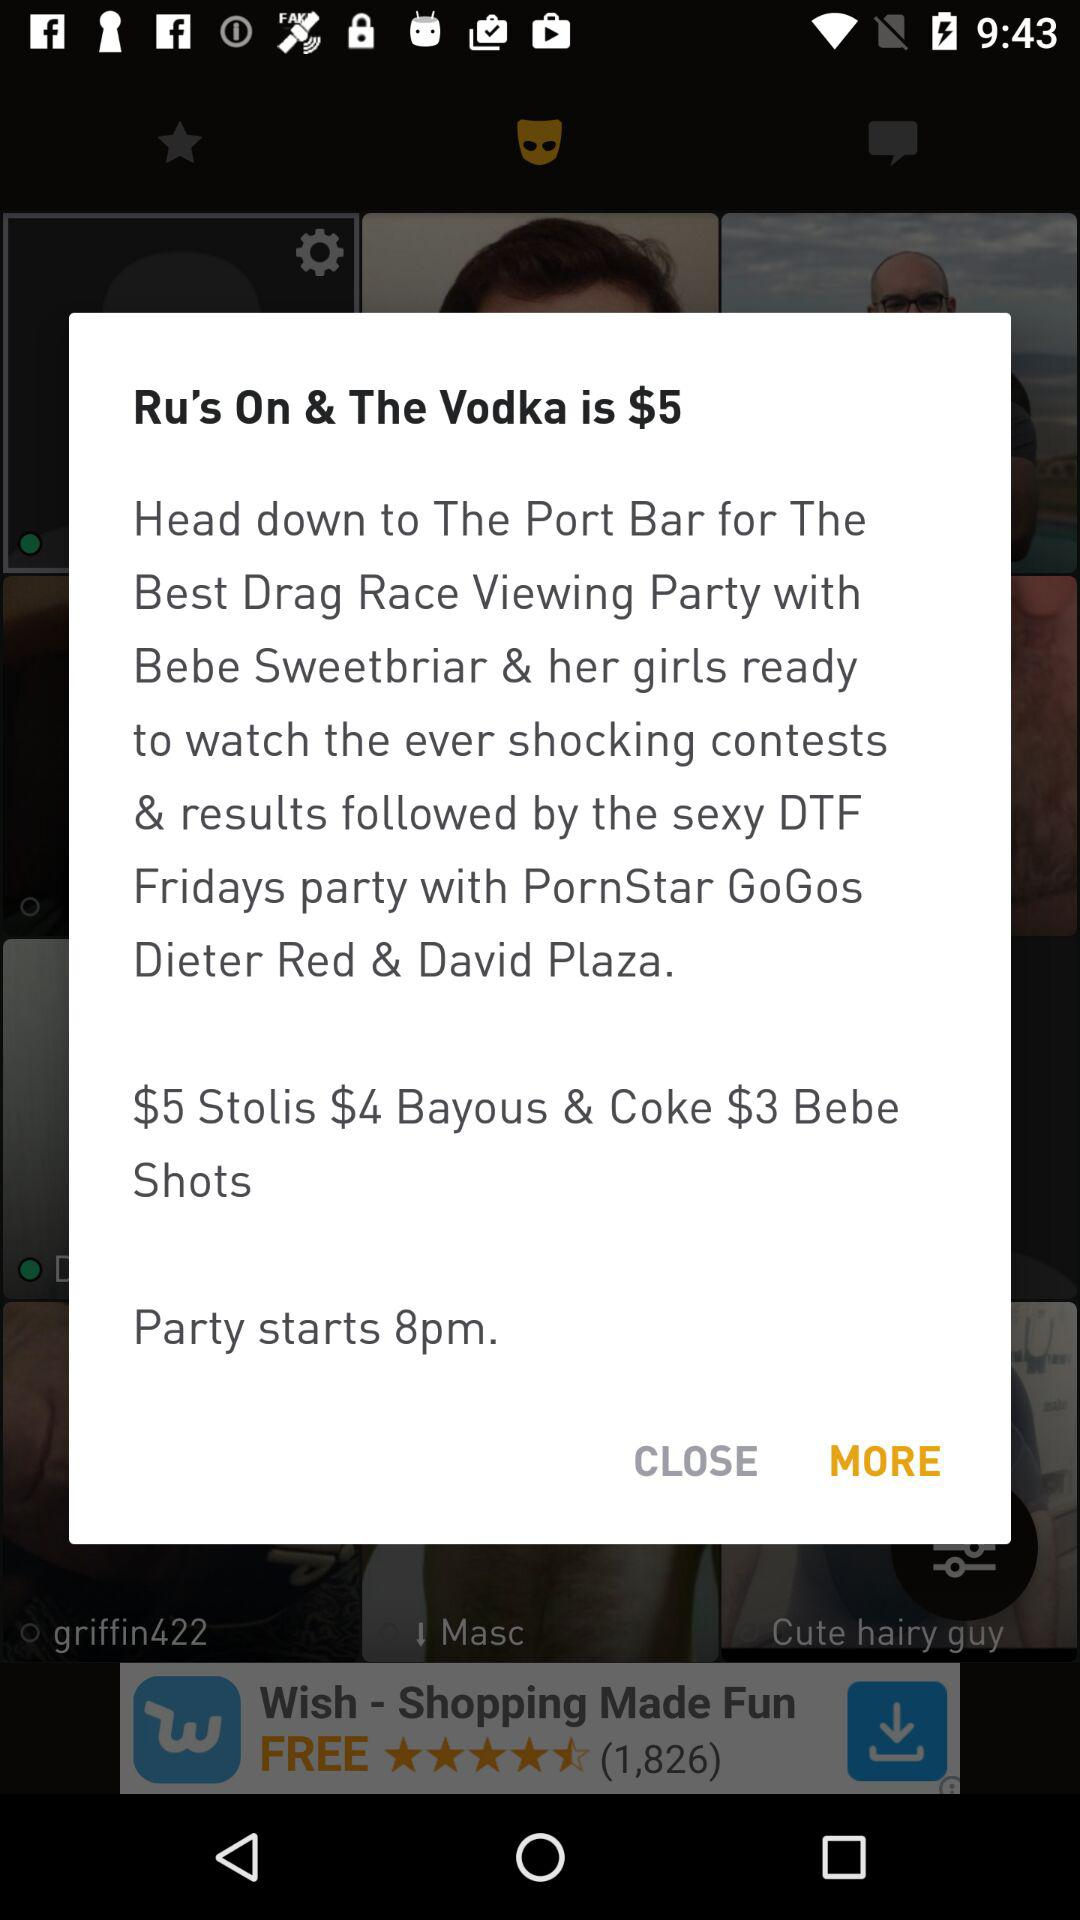How much are Stoli shots?
Answer the question using a single word or phrase. $5 